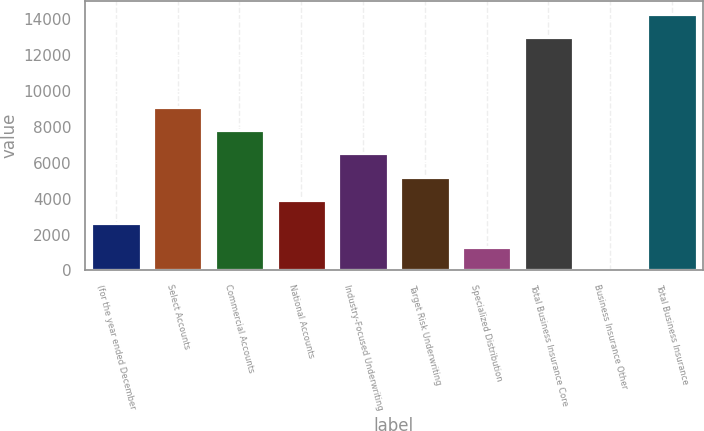Convert chart to OTSL. <chart><loc_0><loc_0><loc_500><loc_500><bar_chart><fcel>(for the year ended December<fcel>Select Accounts<fcel>Commercial Accounts<fcel>National Accounts<fcel>Industry-Focused Underwriting<fcel>Target Risk Underwriting<fcel>Specialized Distribution<fcel>Total Business Insurance Core<fcel>Business Insurance Other<fcel>Total Business Insurance<nl><fcel>2633.4<fcel>9141.9<fcel>7840.2<fcel>3935.1<fcel>6538.5<fcel>5236.8<fcel>1331.7<fcel>13017<fcel>30<fcel>14318.7<nl></chart> 